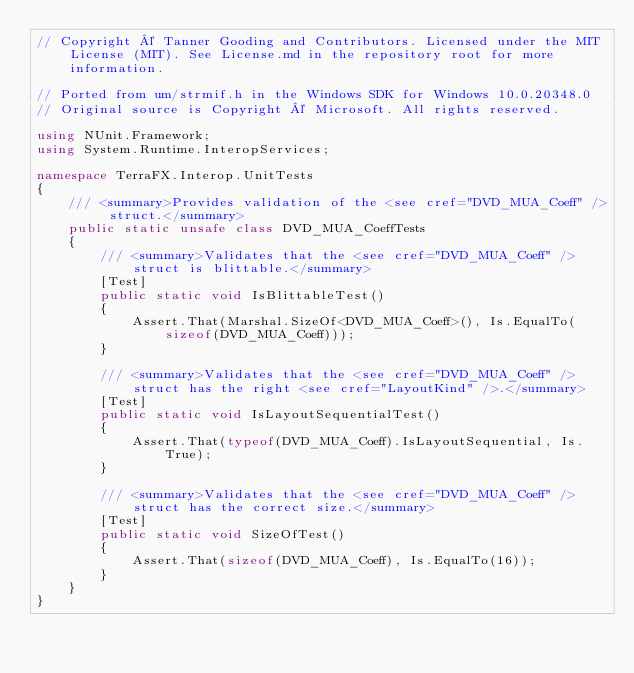<code> <loc_0><loc_0><loc_500><loc_500><_C#_>// Copyright © Tanner Gooding and Contributors. Licensed under the MIT License (MIT). See License.md in the repository root for more information.

// Ported from um/strmif.h in the Windows SDK for Windows 10.0.20348.0
// Original source is Copyright © Microsoft. All rights reserved.

using NUnit.Framework;
using System.Runtime.InteropServices;

namespace TerraFX.Interop.UnitTests
{
    /// <summary>Provides validation of the <see cref="DVD_MUA_Coeff" /> struct.</summary>
    public static unsafe class DVD_MUA_CoeffTests
    {
        /// <summary>Validates that the <see cref="DVD_MUA_Coeff" /> struct is blittable.</summary>
        [Test]
        public static void IsBlittableTest()
        {
            Assert.That(Marshal.SizeOf<DVD_MUA_Coeff>(), Is.EqualTo(sizeof(DVD_MUA_Coeff)));
        }

        /// <summary>Validates that the <see cref="DVD_MUA_Coeff" /> struct has the right <see cref="LayoutKind" />.</summary>
        [Test]
        public static void IsLayoutSequentialTest()
        {
            Assert.That(typeof(DVD_MUA_Coeff).IsLayoutSequential, Is.True);
        }

        /// <summary>Validates that the <see cref="DVD_MUA_Coeff" /> struct has the correct size.</summary>
        [Test]
        public static void SizeOfTest()
        {
            Assert.That(sizeof(DVD_MUA_Coeff), Is.EqualTo(16));
        }
    }
}
</code> 